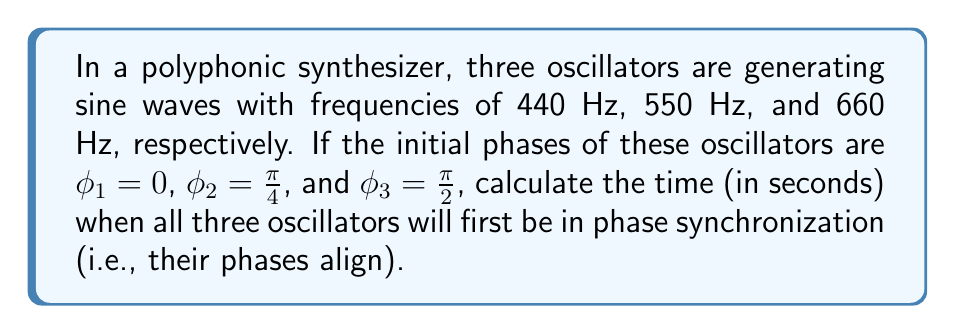Could you help me with this problem? To solve this problem, we need to follow these steps:

1) The phase of each oscillator can be described by the equation:
   $$\phi(t) = 2\pi ft + \phi_0$$
   where $f$ is the frequency, $t$ is time, and $\phi_0$ is the initial phase.

2) For the oscillators to be in phase, their phases must be equal modulo $2\pi$. We can express this as:
   $$2\pi f_1t + \phi_1 \equiv 2\pi f_2t + \phi_2 \equiv 2\pi f_3t + \phi_3 \pmod{2\pi}$$

3) Substituting the given values:
   $$2\pi(440)t + 0 \equiv 2\pi(550)t + \frac{\pi}{4} \equiv 2\pi(660)t + \frac{\pi}{2} \pmod{2\pi}$$

4) For these to be equal, their differences must be multiples of $2\pi$:
   $$2\pi(550-440)t + \frac{\pi}{4} = 2\pi k$$
   $$2\pi(660-440)t + \frac{\pi}{2} = 2\pi m$$
   where $k$ and $m$ are integers.

5) Simplifying:
   $$220\pi t + \frac{\pi}{4} = 2\pi k$$
   $$440\pi t + \frac{\pi}{2} = 2\pi m$$

6) Solving for $t$:
   $$t = \frac{2k - \frac{1}{4}}{220} = \frac{8k - 1}{880}$$
   $$t = \frac{2m - \frac{1}{2}}{440} = \frac{4m - 1}{880}$$

7) For these to be equal, we need the smallest positive integers $k$ and $m$ such that:
   $$8k - 1 = 4m - 1$$
   $$8k = 4m$$
   $$2k = m$$

8) The smallest positive integers satisfying this are $k = 1$ and $m = 2$.

9) Substituting back:
   $$t = \frac{8(1) - 1}{880} = \frac{7}{880} = \frac{1}{125.7142857...} \approx 0.007954545...$$

Therefore, the oscillators will first be in phase synchronization after approximately 0.007954545 seconds.
Answer: $\frac{7}{880}$ seconds 